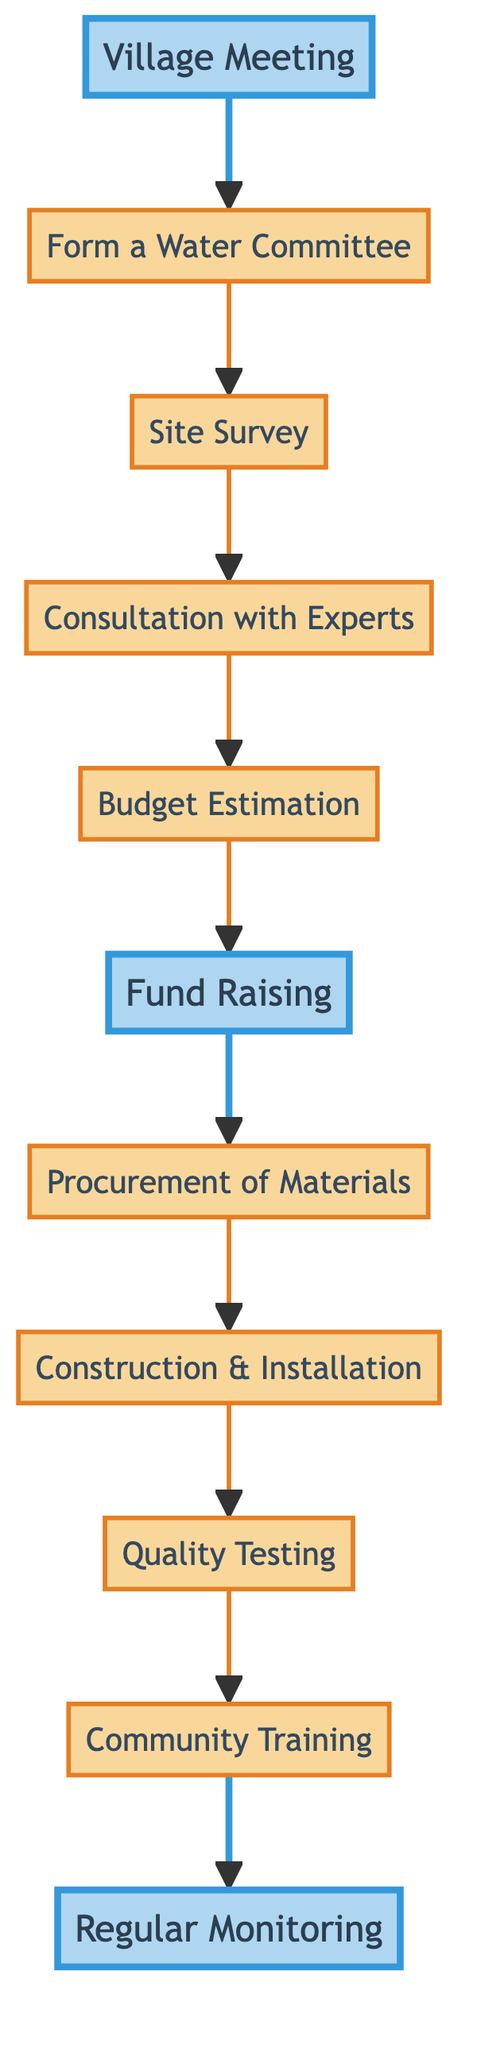What is the first step in the procedure? The first step, as indicated in the diagram, is "Village Meeting," which initiates the process of implementing the clean drinking water project.
Answer: Village Meeting How many main steps are present in the diagram? By counting the distinct steps displayed in the flowchart, we see that there are a total of 11 main steps involved in the procedure.
Answer: 11 What step comes immediately after "Fund Raising"? The diagram shows that the step directly following "Fund Raising" is "Procurement of Materials," indicating a sequential flow of activities.
Answer: Procurement of Materials Which step involves community involvement? "Fund Raising" is the step where community involvement is crucial, as it includes activities to gather support and contributions from the villagers for the project.
Answer: Fund Raising What is the last step in the outlined procedure? The last step outlined in the flowchart is "Regular Monitoring," which emphasizes the ongoing nature of maintaining the water supply after its implementation.
Answer: Regular Monitoring Which two steps are highlighted in the diagram? The two highlighted steps in the diagram are "Village Meeting" and "Fund Raising," indicating their importance in the process.
Answer: Village Meeting, Fund Raising What is the relationship between "Quality Testing" and "Community Training"? The relationship shown in the diagram indicates that "Quality Testing" must be completed before moving on to "Community Training," indicating a dependency in the process.
Answer: Quality Testing precedes Community Training Which step involves professional consultation? The step "Consultation with Experts" clearly denotes the involvement of professionals who provide guidance on the project, making it essential for informed decision-making.
Answer: Consultation with Experts What step follows "Construction & Installation"? According to the flowchart, "Quality Testing" is the subsequent step that follows after "Construction & Installation," ensuring the facilities are safe for use.
Answer: Quality Testing 